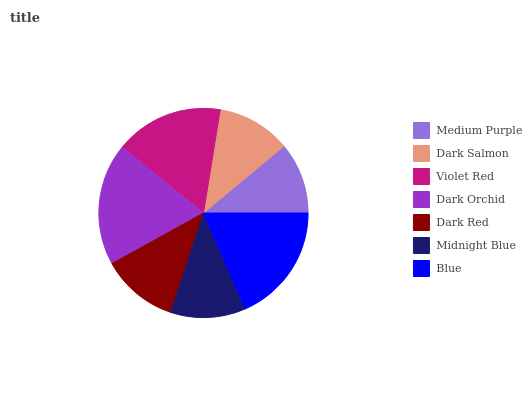Is Medium Purple the minimum?
Answer yes or no. Yes. Is Dark Orchid the maximum?
Answer yes or no. Yes. Is Dark Salmon the minimum?
Answer yes or no. No. Is Dark Salmon the maximum?
Answer yes or no. No. Is Dark Salmon greater than Medium Purple?
Answer yes or no. Yes. Is Medium Purple less than Dark Salmon?
Answer yes or no. Yes. Is Medium Purple greater than Dark Salmon?
Answer yes or no. No. Is Dark Salmon less than Medium Purple?
Answer yes or no. No. Is Dark Red the high median?
Answer yes or no. Yes. Is Dark Red the low median?
Answer yes or no. Yes. Is Midnight Blue the high median?
Answer yes or no. No. Is Dark Salmon the low median?
Answer yes or no. No. 